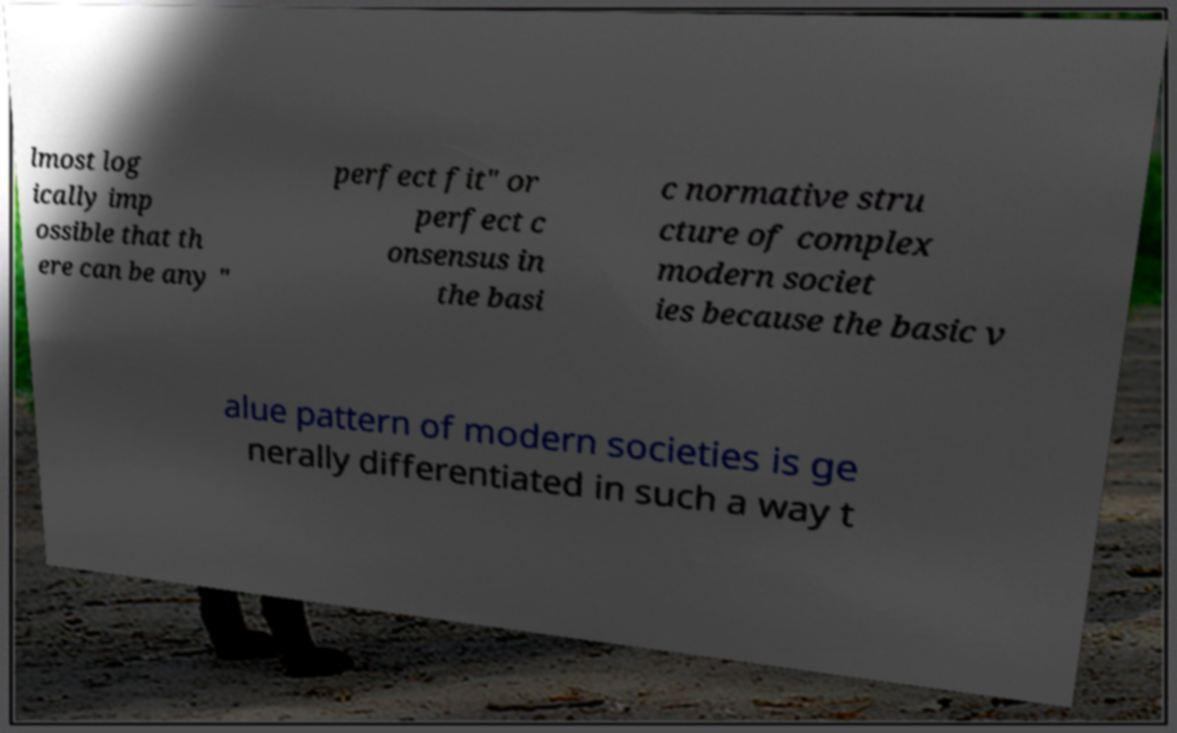Can you accurately transcribe the text from the provided image for me? lmost log ically imp ossible that th ere can be any " perfect fit" or perfect c onsensus in the basi c normative stru cture of complex modern societ ies because the basic v alue pattern of modern societies is ge nerally differentiated in such a way t 